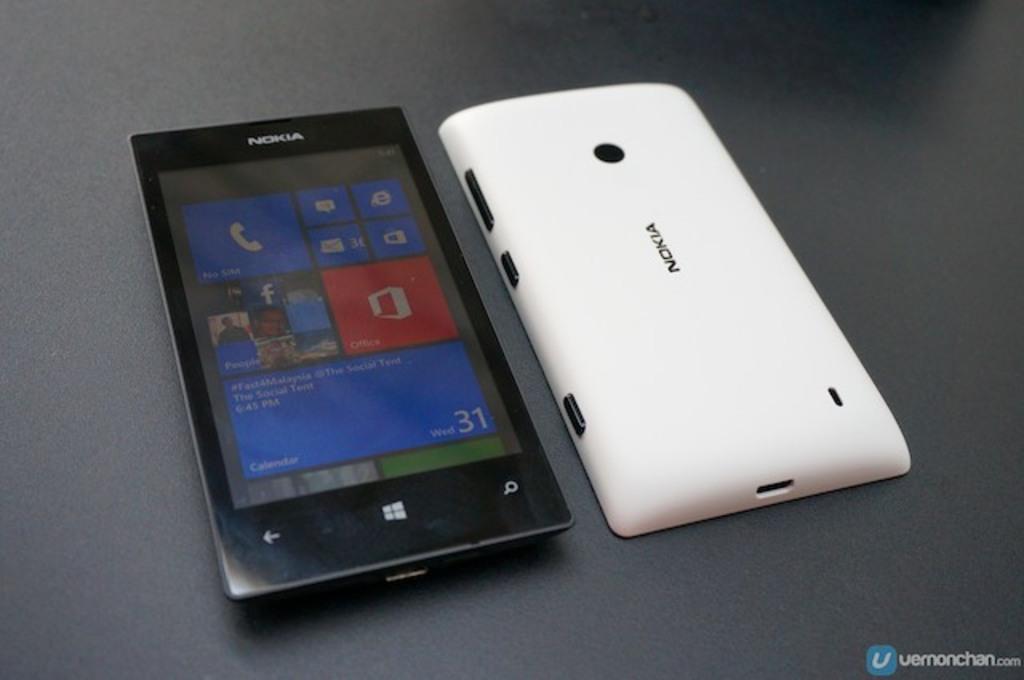What brand of phone is this?
Offer a very short reply. Nokia. What app is shown in the red box?
Provide a short and direct response. Office. 